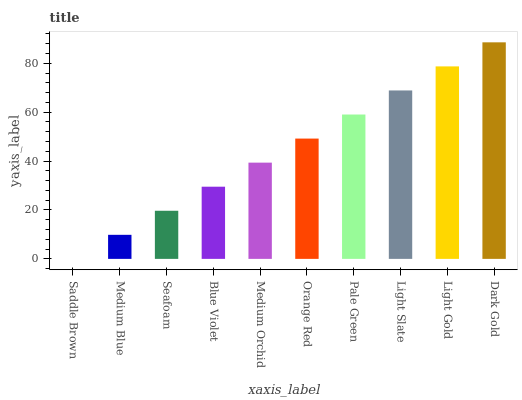Is Saddle Brown the minimum?
Answer yes or no. Yes. Is Dark Gold the maximum?
Answer yes or no. Yes. Is Medium Blue the minimum?
Answer yes or no. No. Is Medium Blue the maximum?
Answer yes or no. No. Is Medium Blue greater than Saddle Brown?
Answer yes or no. Yes. Is Saddle Brown less than Medium Blue?
Answer yes or no. Yes. Is Saddle Brown greater than Medium Blue?
Answer yes or no. No. Is Medium Blue less than Saddle Brown?
Answer yes or no. No. Is Orange Red the high median?
Answer yes or no. Yes. Is Medium Orchid the low median?
Answer yes or no. Yes. Is Seafoam the high median?
Answer yes or no. No. Is Light Gold the low median?
Answer yes or no. No. 